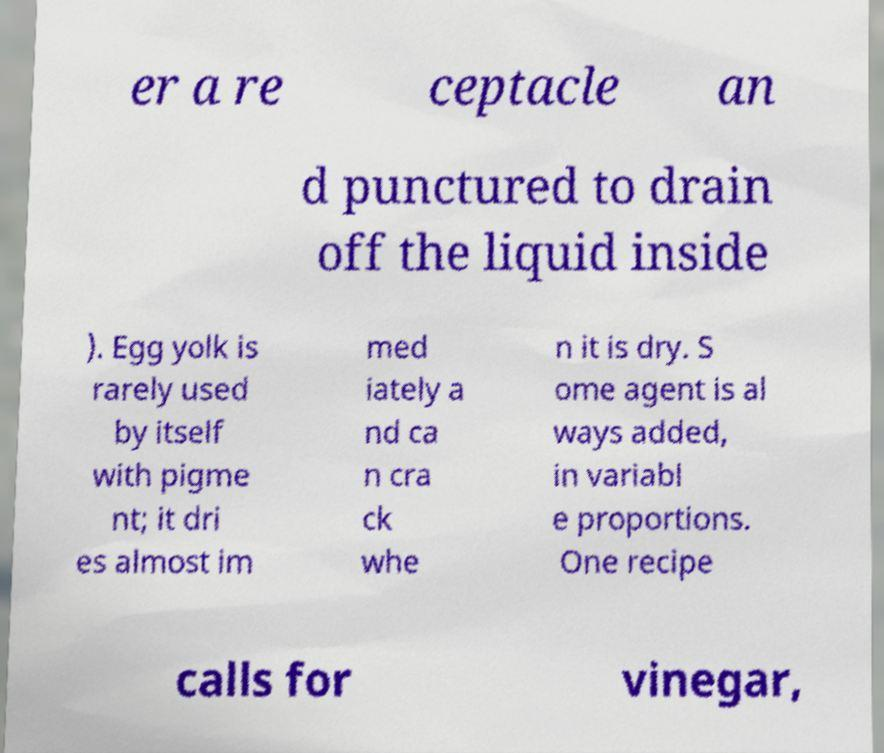Please identify and transcribe the text found in this image. er a re ceptacle an d punctured to drain off the liquid inside ). Egg yolk is rarely used by itself with pigme nt; it dri es almost im med iately a nd ca n cra ck whe n it is dry. S ome agent is al ways added, in variabl e proportions. One recipe calls for vinegar, 